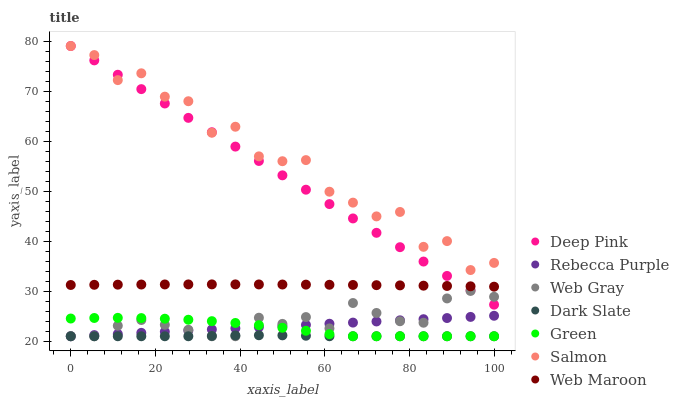Does Dark Slate have the minimum area under the curve?
Answer yes or no. Yes. Does Salmon have the maximum area under the curve?
Answer yes or no. Yes. Does Web Maroon have the minimum area under the curve?
Answer yes or no. No. Does Web Maroon have the maximum area under the curve?
Answer yes or no. No. Is Rebecca Purple the smoothest?
Answer yes or no. Yes. Is Salmon the roughest?
Answer yes or no. Yes. Is Web Maroon the smoothest?
Answer yes or no. No. Is Web Maroon the roughest?
Answer yes or no. No. Does Dark Slate have the lowest value?
Answer yes or no. Yes. Does Web Maroon have the lowest value?
Answer yes or no. No. Does Salmon have the highest value?
Answer yes or no. Yes. Does Web Maroon have the highest value?
Answer yes or no. No. Is Green less than Web Maroon?
Answer yes or no. Yes. Is Salmon greater than Green?
Answer yes or no. Yes. Does Green intersect Dark Slate?
Answer yes or no. Yes. Is Green less than Dark Slate?
Answer yes or no. No. Is Green greater than Dark Slate?
Answer yes or no. No. Does Green intersect Web Maroon?
Answer yes or no. No. 